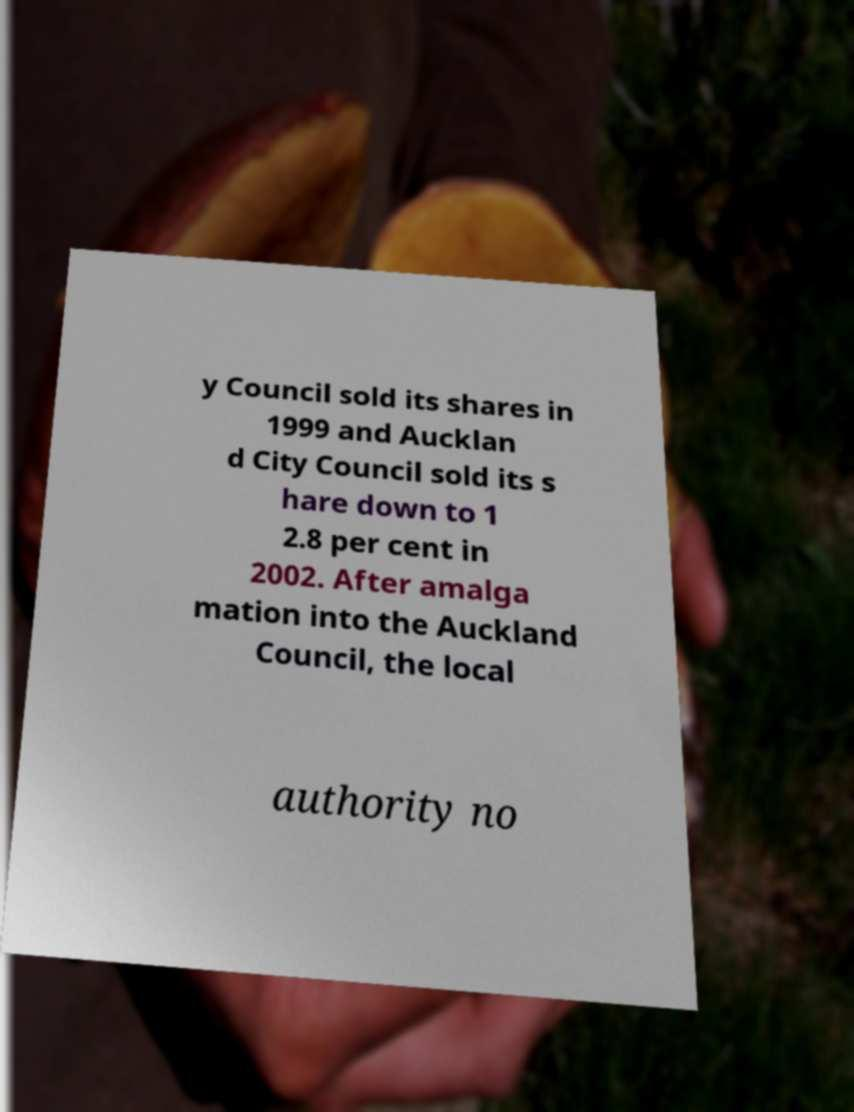There's text embedded in this image that I need extracted. Can you transcribe it verbatim? y Council sold its shares in 1999 and Aucklan d City Council sold its s hare down to 1 2.8 per cent in 2002. After amalga mation into the Auckland Council, the local authority no 